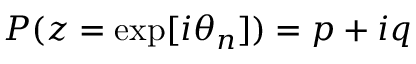Convert formula to latex. <formula><loc_0><loc_0><loc_500><loc_500>P ( z = \exp [ i \theta _ { n } ] ) = p + i q</formula> 